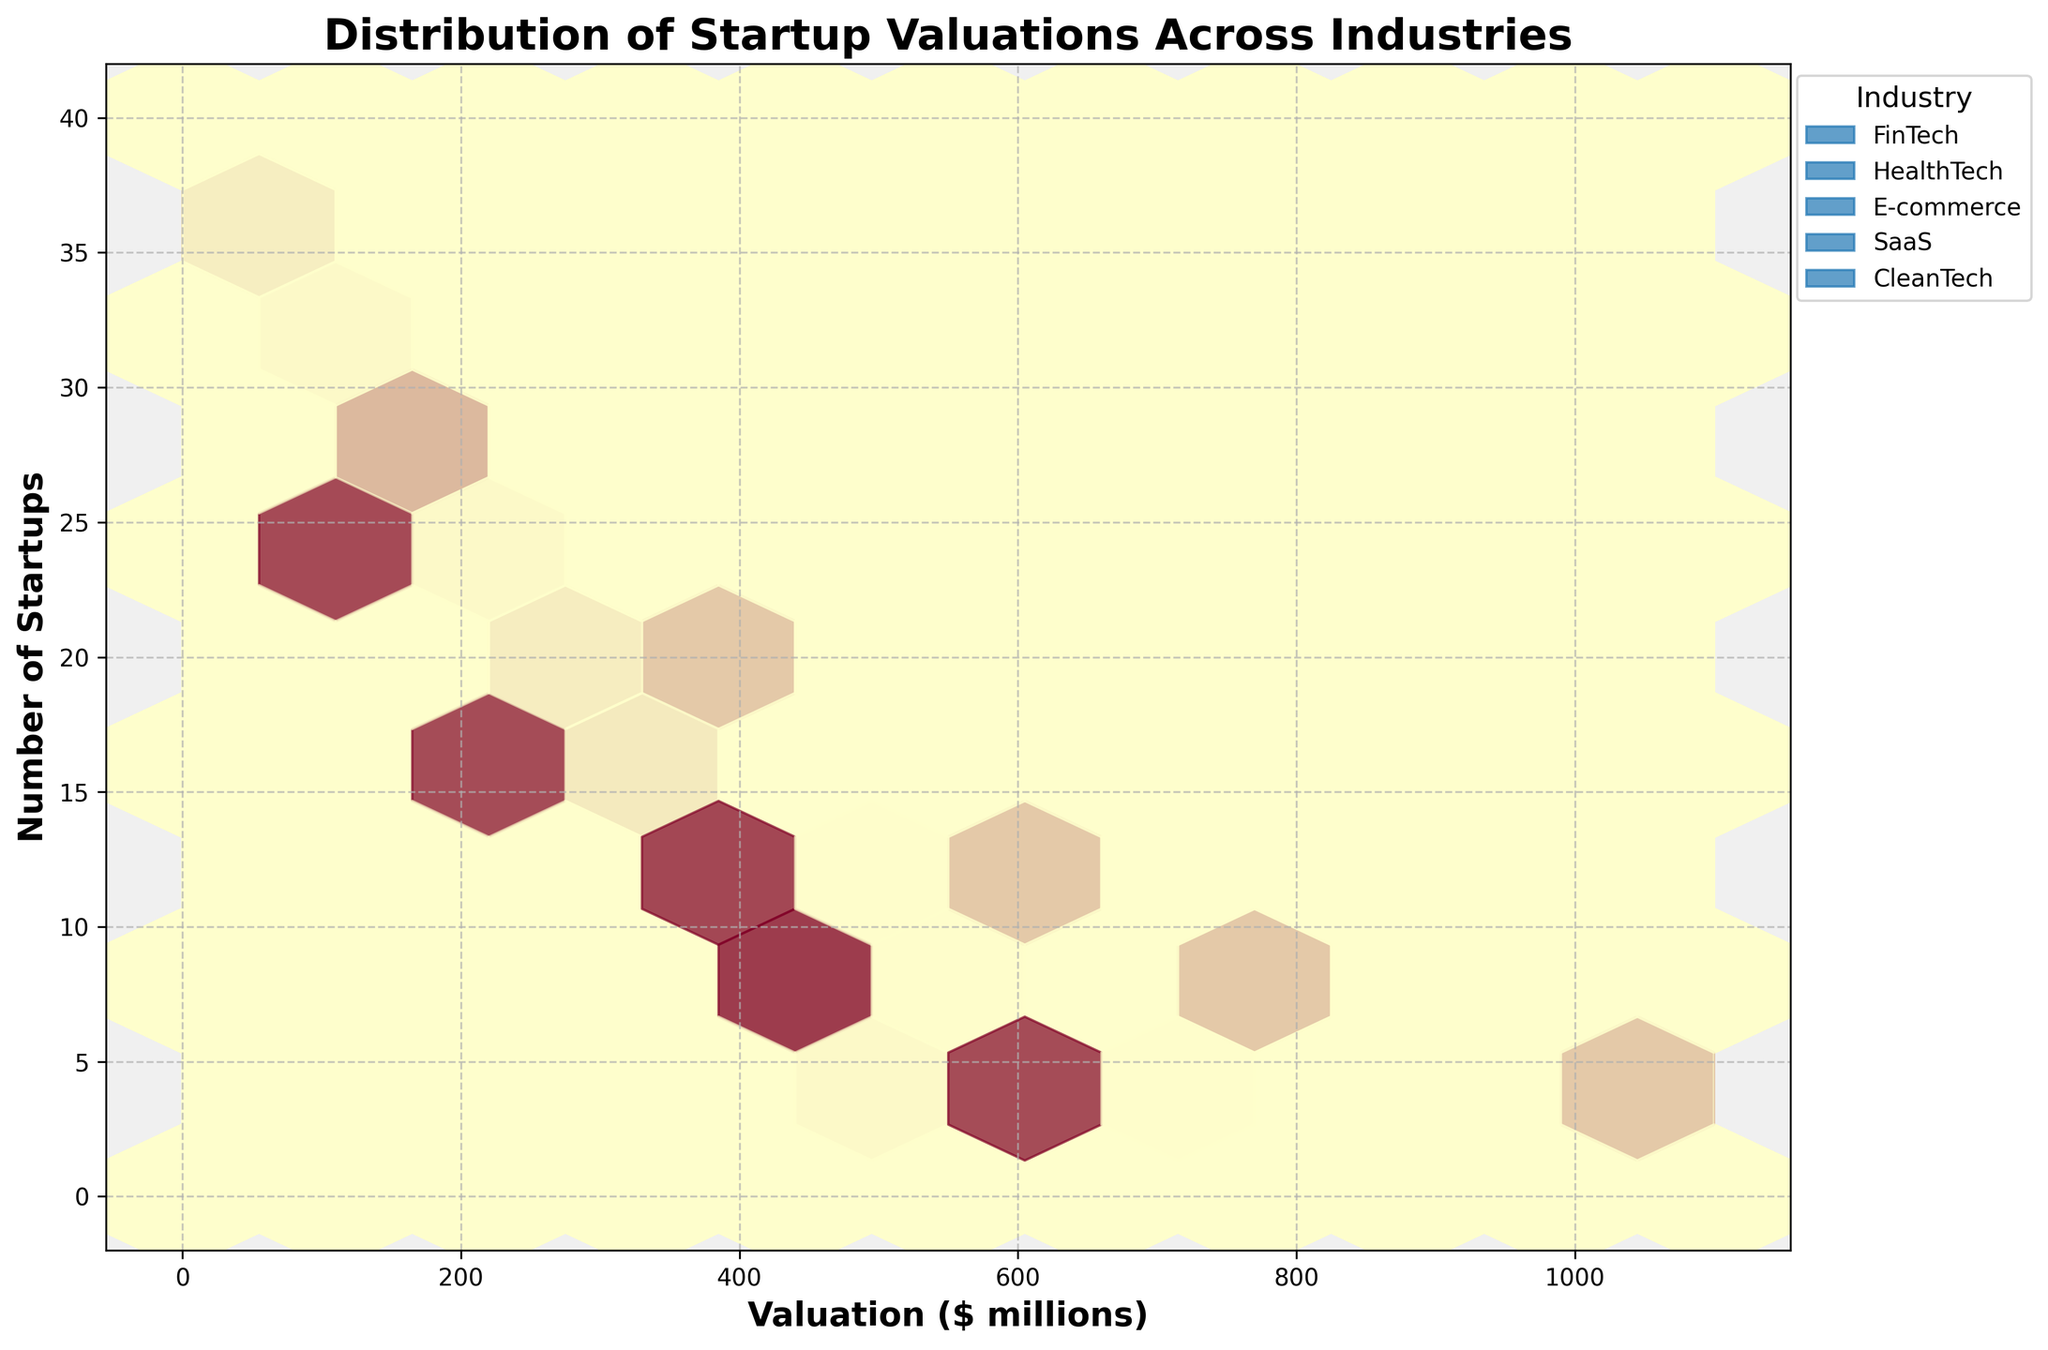What's the title of the plot? The title is usually located at the top of the plot. By looking at the plot, we can directly read the title from there.
Answer: Distribution of Startup Valuations Across Industries What are the units on the x-axis? The x-axis is labeled with the units that describe the valuation of startups. By checking the x-axis label, we see it represents valuation in millions of dollars.
Answer: Valuation ($ millions) Which industry has the highest concentration of startups with valuations between $200 million and $400 million? To find this, we observe the hexagons between $200 and $400 million on the x-axis. The industry with the highest density (most colored hexagons) in this range is HealthTech.
Answer: HealthTech How many unique industries are represented in the plot? We can identify this by counting the number of unique color-coded labels presented in the legend on the plot. The legend lists five industries.
Answer: 5 In which valuation range do FinTech startups appear most frequently? We need to look at the concentration of hexagons along the x-axis for FinTech. The highest density appears between $150 million and $300 million.
Answer: $150 million to $300 million Which industry has the widest range of startup valuations? The widest range can be found by comparing the spread of hexagons for each industry on the x-axis. SaaS has valuations ranging from $200 million to $1 billion, indicating the widest range.
Answer: SaaS In which valuation range does E-commerce have the fewest startups? By examining the hexagon density for E-commerce across the x-axis, the fewest startups are seen between $320 million and $400 million.
Answer: $320 million to $400 million Compared to CleanTech, does HealthTech generally have more or fewer startups in the $300 million to $400 million valuation range? We compare the hexagon density for both industries within the $300 million to $400 million range on the x-axis. HealthTech shows a higher density, meaning it has more startups.
Answer: More For SaaS startups, what is the number of startups roughly between $600 million to $800 million valuations? To determine this, look at the density and count the hexagons with SaaS labels in the $600 million to $800 million valuation range on the x-axis. It appears to be around 14 startups.
Answer: 14 